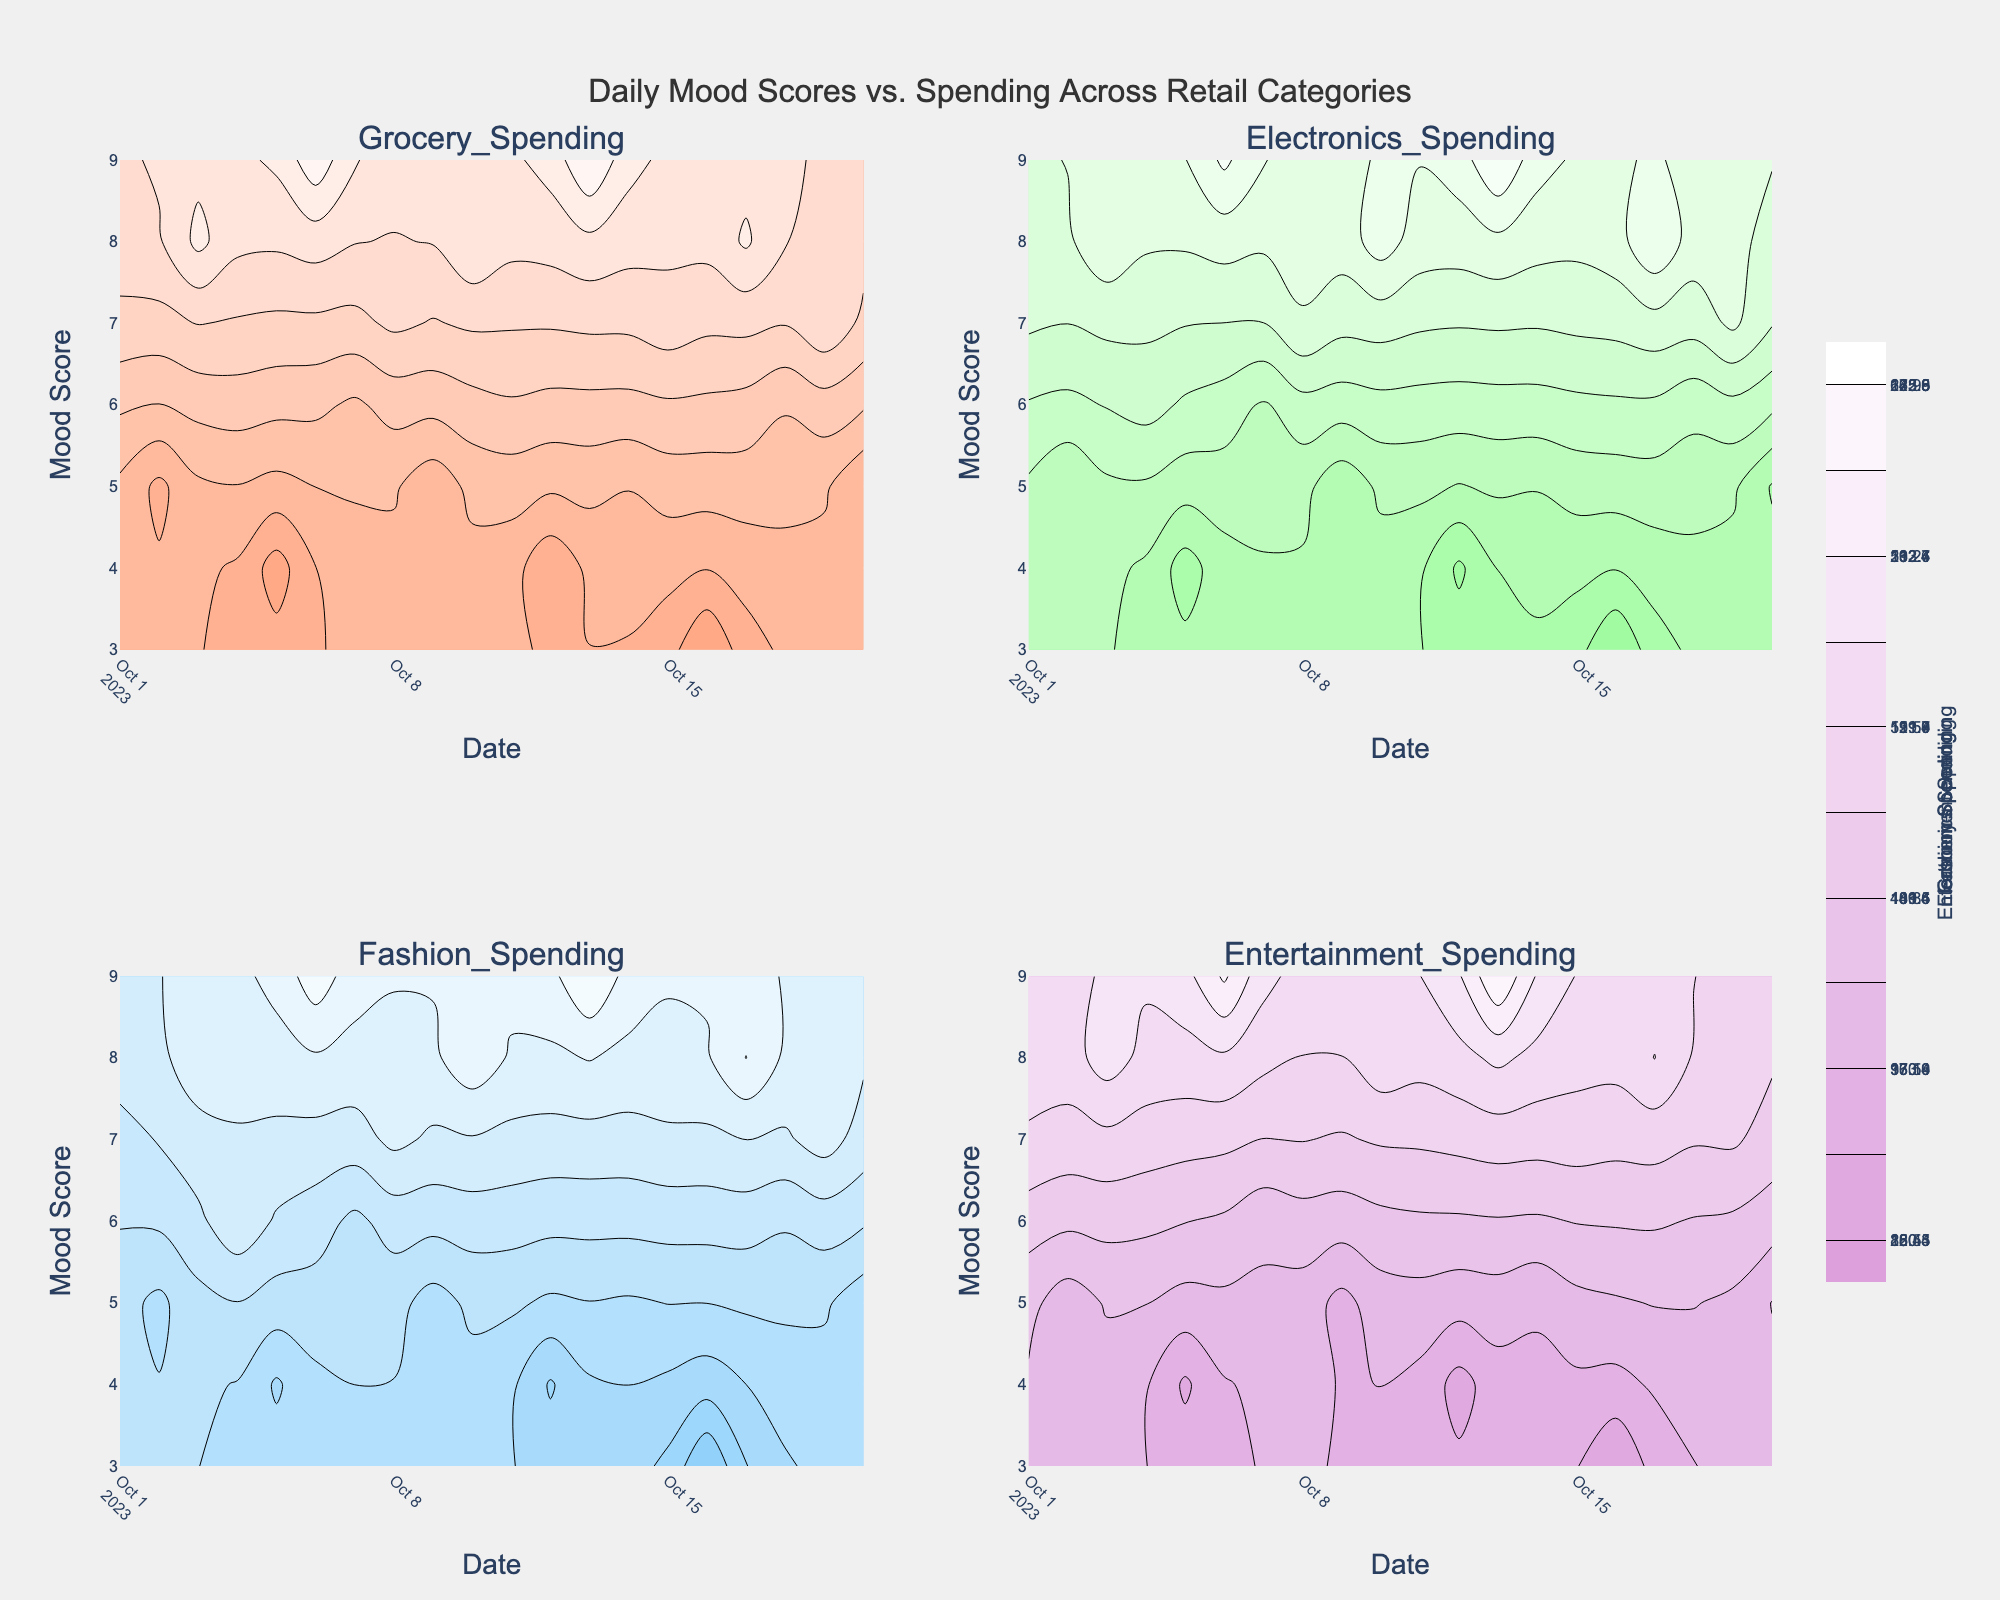What is the title of the figure? The title of the figure is displayed at the top-center. It reads "Daily Mood Scores vs. Spending Across Retail Categories".
Answer: Daily Mood Scores vs. Spending Across Retail Categories How many subplot categories are there in this figure? The figure shows four subplot categories, as indicated by the subplot titles. The categories are Grocery Spending, Electronics Spending, Fashion Spending, and Entertainment Spending.
Answer: 4 What is the color of the highest spending amounts in the contours? The highest spending amounts in the contours are represented by the colors fading from distinct category colors (e.g., salmon, light green, light blue, light purple) to white.
Answer: white What information does the y-axis represent in each subplot? The y-axis in each subplot represents Mood Score, which ranges from the lowest to the highest recorded mood scores.
Answer: Mood Score How are the dates represented on the x-axis? The dates on the x-axis are spaced along the horizontal axis with a slight angle for better readability. They are incrementally listed from the start to the end of the dataset.
Answer: Horizontal axis in incremental order What is the approximate average spending amount in the Electronics category? To find the average, sum all the Electronics Spending values and divide by the number of data points. Sum: 200.49 + 180.50 + 210.75 + 195.33 + 170.28 + 220.42 + 185.50 + 205.36 + 175.39 + 215.54 + 190.45 + 165.62 + 225.47 + 180.20 + 200.89 + 160.33 + 218.23 + 188.45 + 207.29 + 172.80. Sum = 3943.30. Number of data points = 20. Average = 3943.30 / 20.
Answer: 197.17 What is the difference in spending on Fashion between the highest and lowest mood scores? Identify the highest (Mood_Score = 9) and lowest (Mood_Score = 3) mood scores, then their respective Fashion Spending values. The highest: 172.85, the lowest: 120.40. Difference = 172.85 - 120.40.
Answer: 52.45 On which dates does a mood score of 8 correspond to the highest spending in any category? Scan for spending amounts on dates with a Mood Score of 8: 2023-10-03, 2023-10-10, 2023-10-17. Compare amounts in each category: Grocery (60.32, 58.90, 59.87), Electronics (210.75, 215.54, 218.23), Fashion (160.45, 165.85, 167.70), Entertainment (130.52, 125.43, 127.70). 2023-10-17 has the highest Electronics spending of 218.23.
Answer: 2023-10-17 Which category has the least amount of spending on a mood score of 4? Identify the spending amounts on 2023-10-05 and 2023-10-12: Grocery (30.45, 33.20), Electronics (170.28, 165.62), Fashion (135.40, 130.30), Entertainment (90.45, 89.20). The lowest spending amount is in Entertainment on both dates: 89.20.
Answer: Entertainment Spending How does the spending pattern in the Grocery category vary with mood scores? Observe the contour patterns and colors in the Grocery Spending subplot across different Mood Scores. Higher mood scores show generally higher spending highlighted by deeper colors, while lower mood scores show lower spending with lighter shades.
Answer: Higher mood scores show higher spending amounts In which category is the variation in spending most distinctly shown as mood changes? Observe the contours for each category: Electronics, Fashion, and Grocery Spending show more varied contours, whereas Entertainment has more consistent and uniform contours. Electronics shows the most distinct variation with changes in mood.
Answer: Electronics 